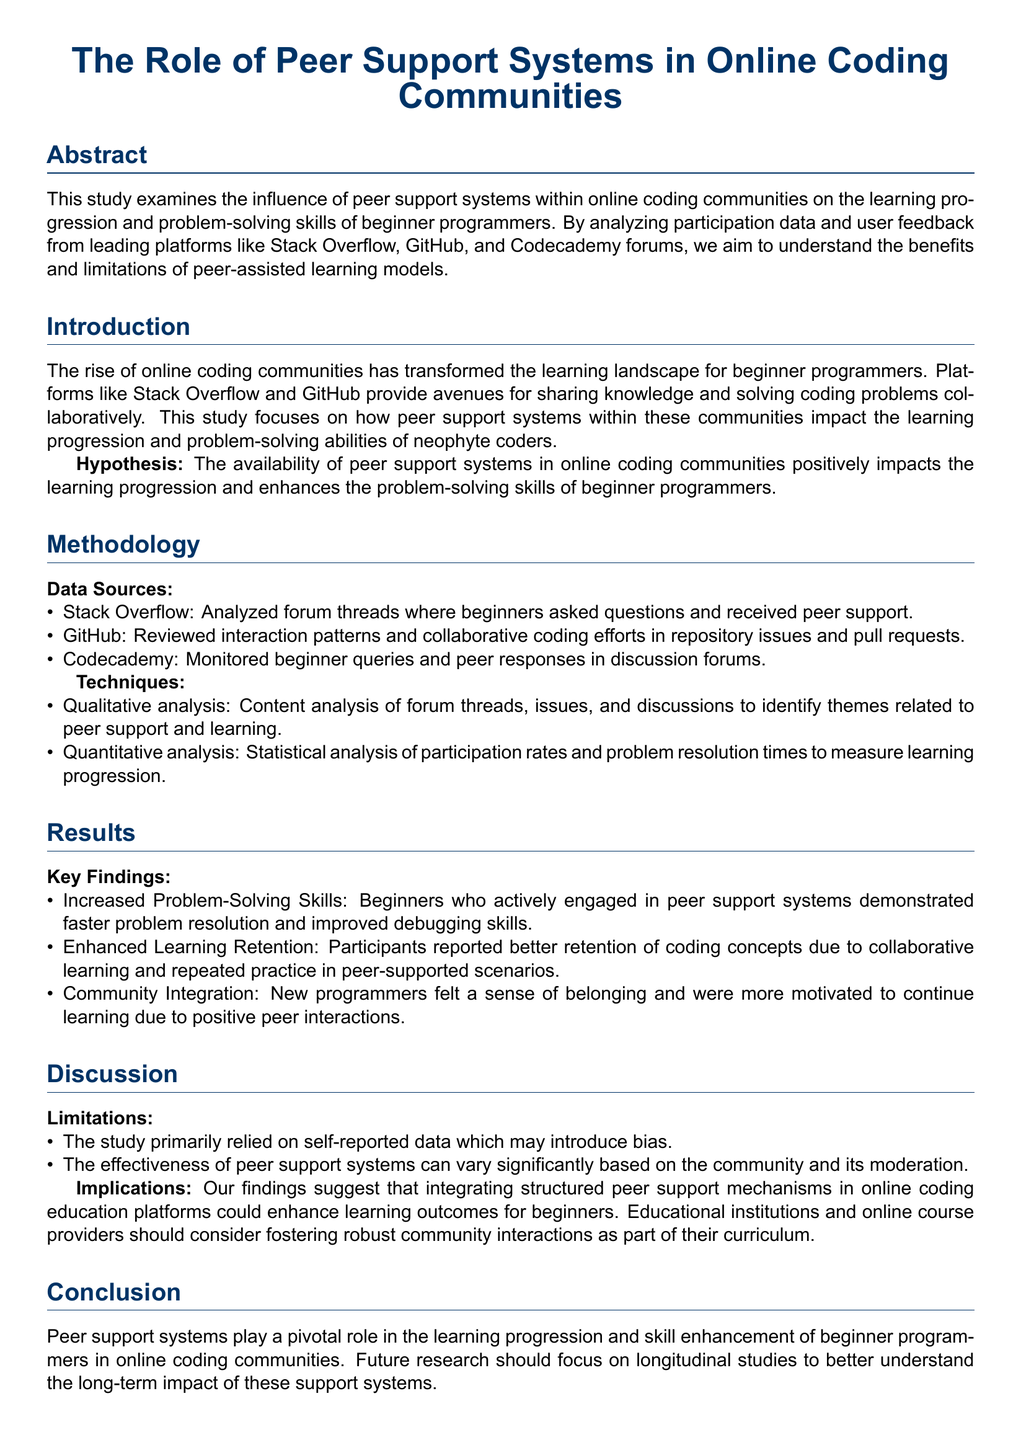What is the title of the study? The title is listed at the top of the document, summarizing the focus of the research.
Answer: The Role of Peer Support Systems in Online Coding Communities What platforms were analyzed in the study? The document lists specific platforms in the Data Sources section where data was collected for analysis.
Answer: Stack Overflow, GitHub, Codecademy What is the main hypothesis of the study? The hypothesis is stated in the Introduction section and highlights the anticipated outcome of peer support systems.
Answer: Peer support systems positively impact learning progression Which method was used for qualitative analysis? The Methodology section details the techniques employed, including qualitative analysis methods.
Answer: Content analysis What was a key finding related to problem-solving skills? The Results section presents findings on the impact of peer support systems on problem-solving abilities.
Answer: Increased Problem-Solving Skills What did participants say about learning retention? The Results section describes the findings regarding participants' experiences with learning and retention.
Answer: Enhanced Learning Retention What limitation is mentioned in the study? The document lists specific limitations in the Discussion section that may affect the reliability of the findings.
Answer: Self-reported data What is suggested for educational institutions based on the findings? The Implications section offers recommendations for future practices in coding education based on the study results.
Answer: Foster robust community interactions 